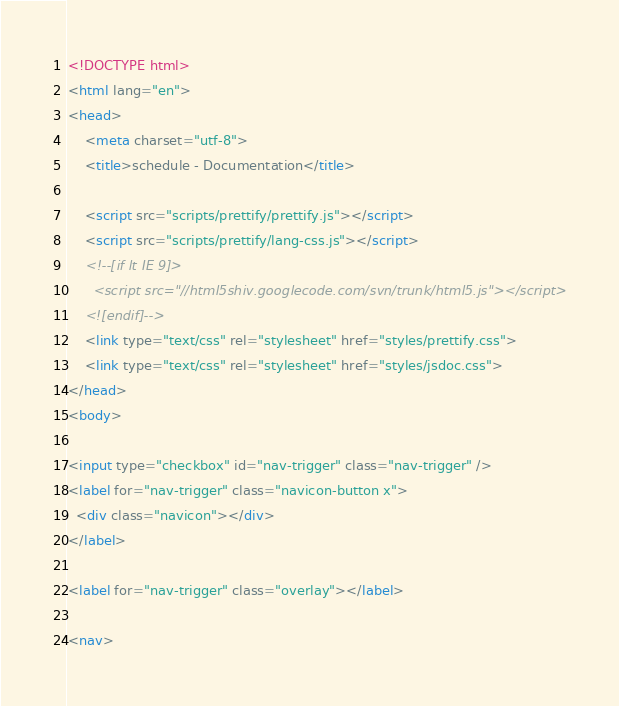Convert code to text. <code><loc_0><loc_0><loc_500><loc_500><_HTML_><!DOCTYPE html>
<html lang="en">
<head>
    <meta charset="utf-8">
    <title>schedule - Documentation</title>

    <script src="scripts/prettify/prettify.js"></script>
    <script src="scripts/prettify/lang-css.js"></script>
    <!--[if lt IE 9]>
      <script src="//html5shiv.googlecode.com/svn/trunk/html5.js"></script>
    <![endif]-->
    <link type="text/css" rel="stylesheet" href="styles/prettify.css">
    <link type="text/css" rel="stylesheet" href="styles/jsdoc.css">
</head>
<body>

<input type="checkbox" id="nav-trigger" class="nav-trigger" />
<label for="nav-trigger" class="navicon-button x">
  <div class="navicon"></div>
</label>

<label for="nav-trigger" class="overlay"></label>

<nav></code> 